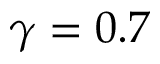Convert formula to latex. <formula><loc_0><loc_0><loc_500><loc_500>\gamma = 0 . 7</formula> 